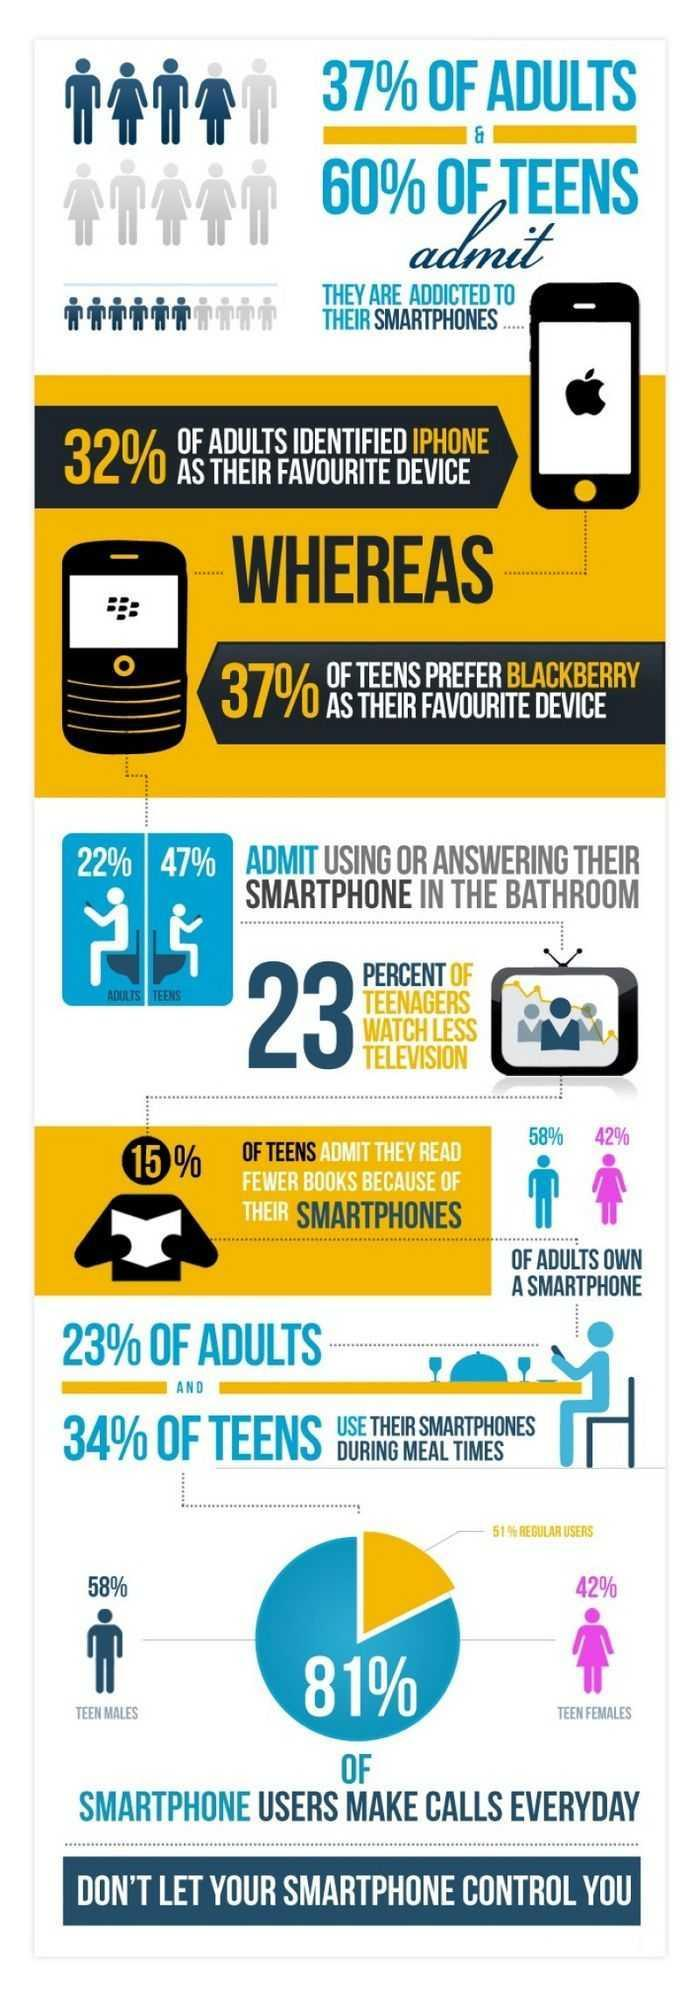What percentage of adults use their smartphones during meal times?
Answer the question with a short phrase. 23% Which phone is the favorite device of teens? Blackberry How many teens read fewer books because of their Smartphones? 15% Which phone is the favorite device of adults? iPhone How many teens use their smartphones to make calls everyday? 81% Of the 81% of teens using their smartphones to make calls everyday, how many are females? 42% Who use their smartphone or answer their smartphone more while in the bathroom? Teens How many more men own smartphones than women? 16% 